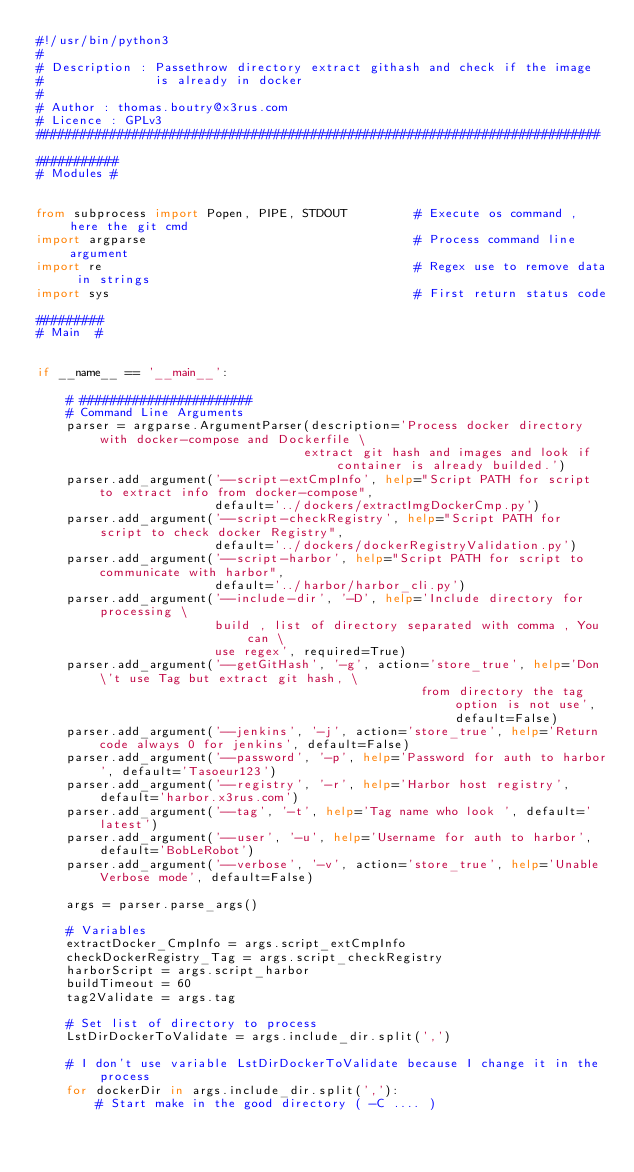Convert code to text. <code><loc_0><loc_0><loc_500><loc_500><_Python_>#!/usr/bin/python3
#
# Description : Passethrow directory extract githash and check if the image
#               is already in docker
#
# Author : thomas.boutry@x3rus.com
# Licence : GPLv3
############################################################################

###########
# Modules #


from subprocess import Popen, PIPE, STDOUT         # Execute os command , here the git cmd
import argparse                                    # Process command line argument
import re                                          # Regex use to remove data in strings
import sys                                         # First return status code

#########
# Main  #


if __name__ == '__main__':

    # #######################
    # Command Line Arguments
    parser = argparse.ArgumentParser(description='Process docker directory with docker-compose and Dockerfile \
                                    extract git hash and images and look if container is already builded.')
    parser.add_argument('--script-extCmpInfo', help="Script PATH for script to extract info from docker-compose",
                        default='../dockers/extractImgDockerCmp.py')
    parser.add_argument('--script-checkRegistry', help="Script PATH for script to check docker Registry",
                        default='../dockers/dockerRegistryValidation.py')
    parser.add_argument('--script-harbor', help="Script PATH for script to communicate with harbor",
                        default='../harbor/harbor_cli.py')
    parser.add_argument('--include-dir', '-D', help='Include directory for processing \
                        build , list of directory separated with comma , You can \
                        use regex', required=True)
    parser.add_argument('--getGitHash', '-g', action='store_true', help='Don\'t use Tag but extract git hash, \
                                                    from directory the tag option is not use', default=False)
    parser.add_argument('--jenkins', '-j', action='store_true', help='Return code always 0 for jenkins', default=False)
    parser.add_argument('--password', '-p', help='Password for auth to harbor', default='Tasoeur123')
    parser.add_argument('--registry', '-r', help='Harbor host registry', default='harbor.x3rus.com')
    parser.add_argument('--tag', '-t', help='Tag name who look ', default='latest')
    parser.add_argument('--user', '-u', help='Username for auth to harbor', default='BobLeRobot')
    parser.add_argument('--verbose', '-v', action='store_true', help='Unable Verbose mode', default=False)

    args = parser.parse_args()

    # Variables
    extractDocker_CmpInfo = args.script_extCmpInfo
    checkDockerRegistry_Tag = args.script_checkRegistry
    harborScript = args.script_harbor
    buildTimeout = 60
    tag2Validate = args.tag

    # Set list of directory to process
    LstDirDockerToValidate = args.include_dir.split(',')

    # I don't use variable LstDirDockerToValidate because I change it in the process
    for dockerDir in args.include_dir.split(','):
        # Start make in the good directory ( -C .... )</code> 